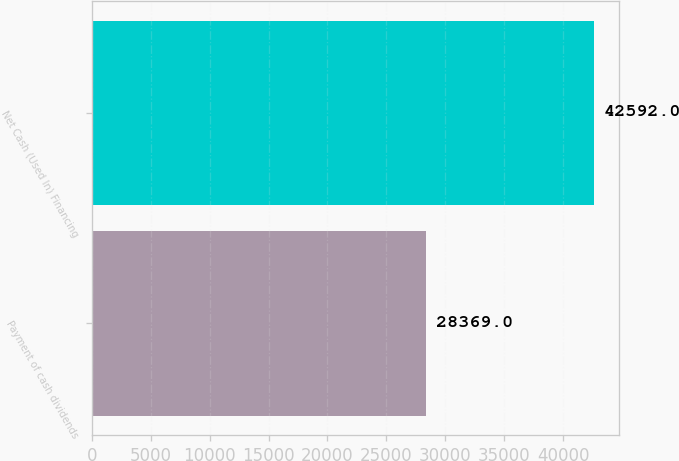<chart> <loc_0><loc_0><loc_500><loc_500><bar_chart><fcel>Payment of cash dividends<fcel>Net Cash (Used In) Financing<nl><fcel>28369<fcel>42592<nl></chart> 